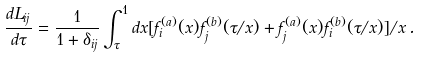Convert formula to latex. <formula><loc_0><loc_0><loc_500><loc_500>\frac { d L _ { i j } } { d \tau } = \frac { 1 } { 1 + \delta _ { i j } } \int ^ { 1 } _ { \tau } d x [ f ^ { ( a ) } _ { i } ( x ) f ^ { ( b ) } _ { j } ( \tau / x ) + f ^ { ( a ) } _ { j } ( x ) f ^ { ( b ) } _ { i } ( \tau / x ) ] / x \, .</formula> 